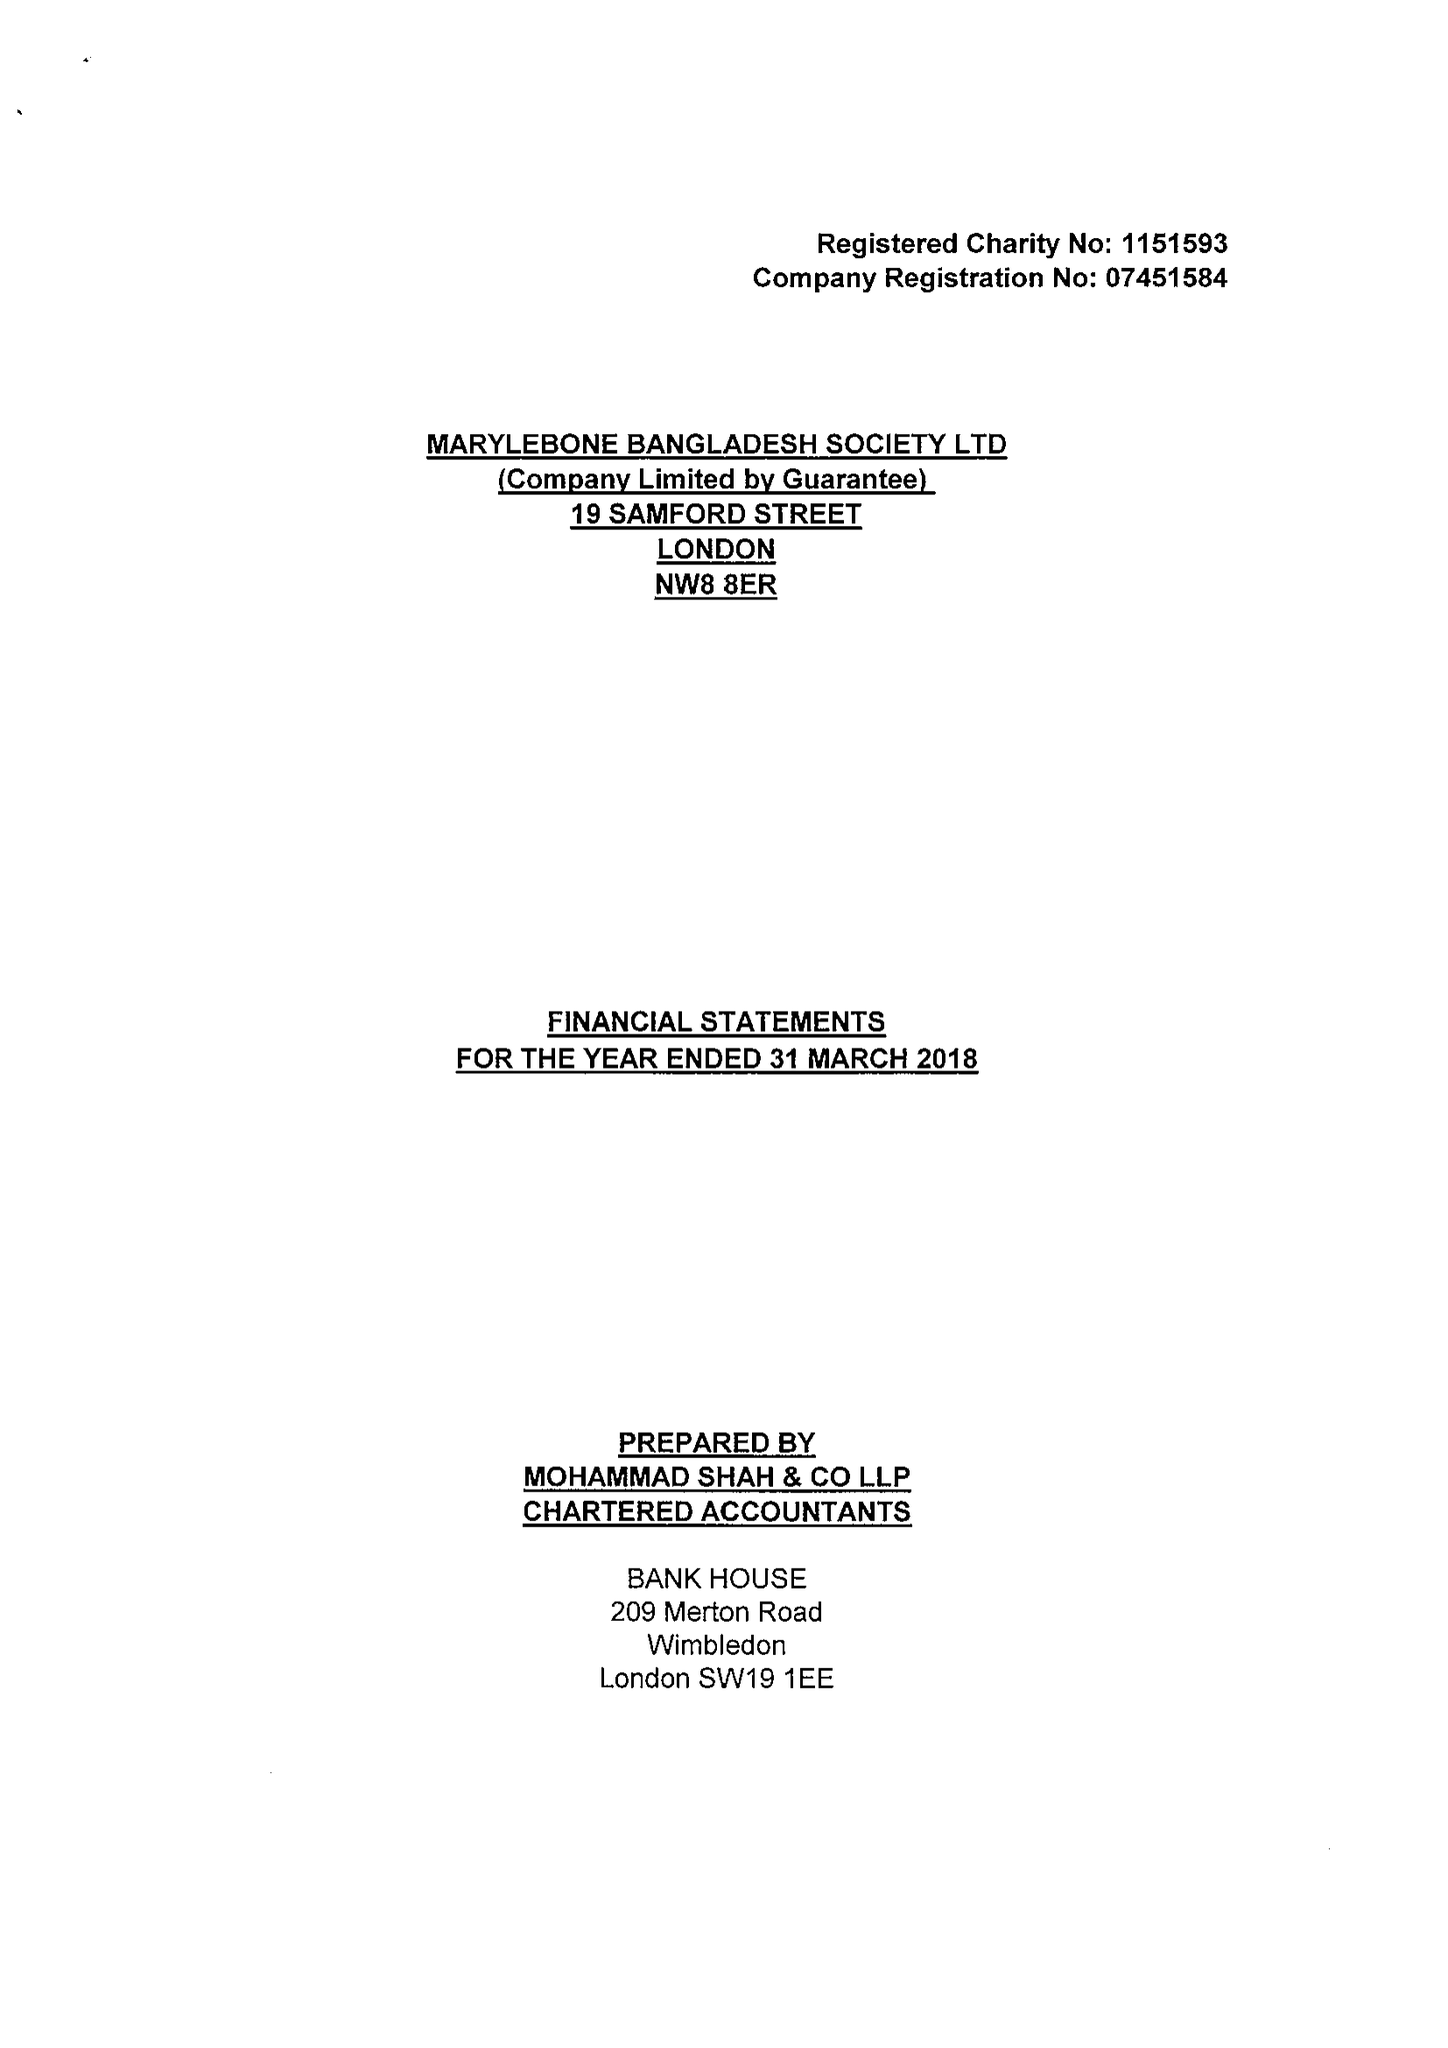What is the value for the address__post_town?
Answer the question using a single word or phrase. LONDON 